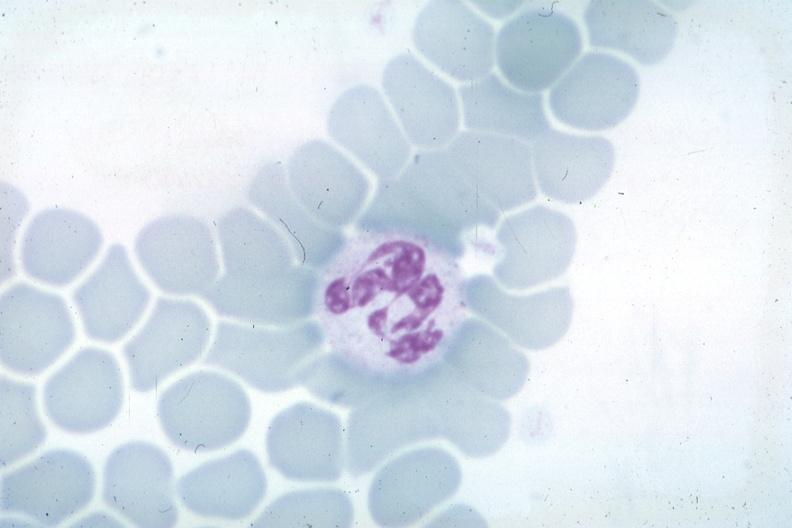s blood present?
Answer the question using a single word or phrase. Yes 